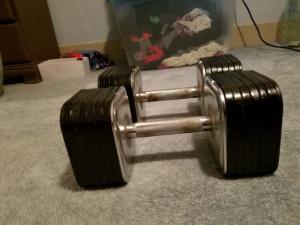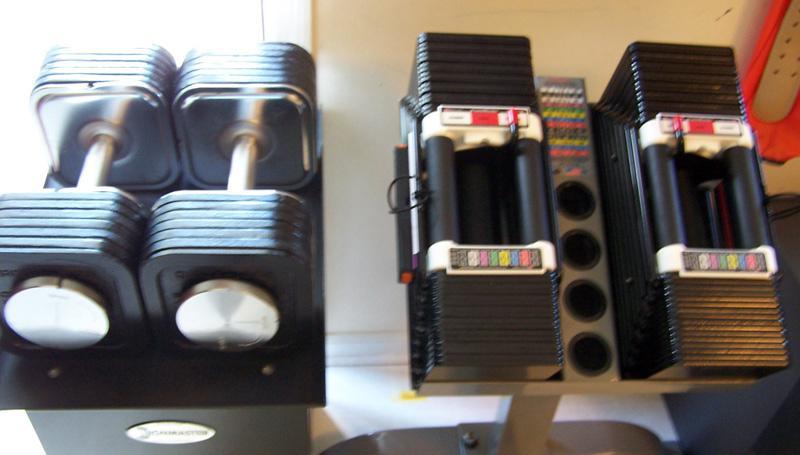The first image is the image on the left, the second image is the image on the right. Examine the images to the left and right. Is the description "There is a single dumbbell in the left image." accurate? Answer yes or no. No. The first image is the image on the left, the second image is the image on the right. Considering the images on both sides, is "There is a total of three dumbells with six sets of circle weights on it." valid? Answer yes or no. No. 